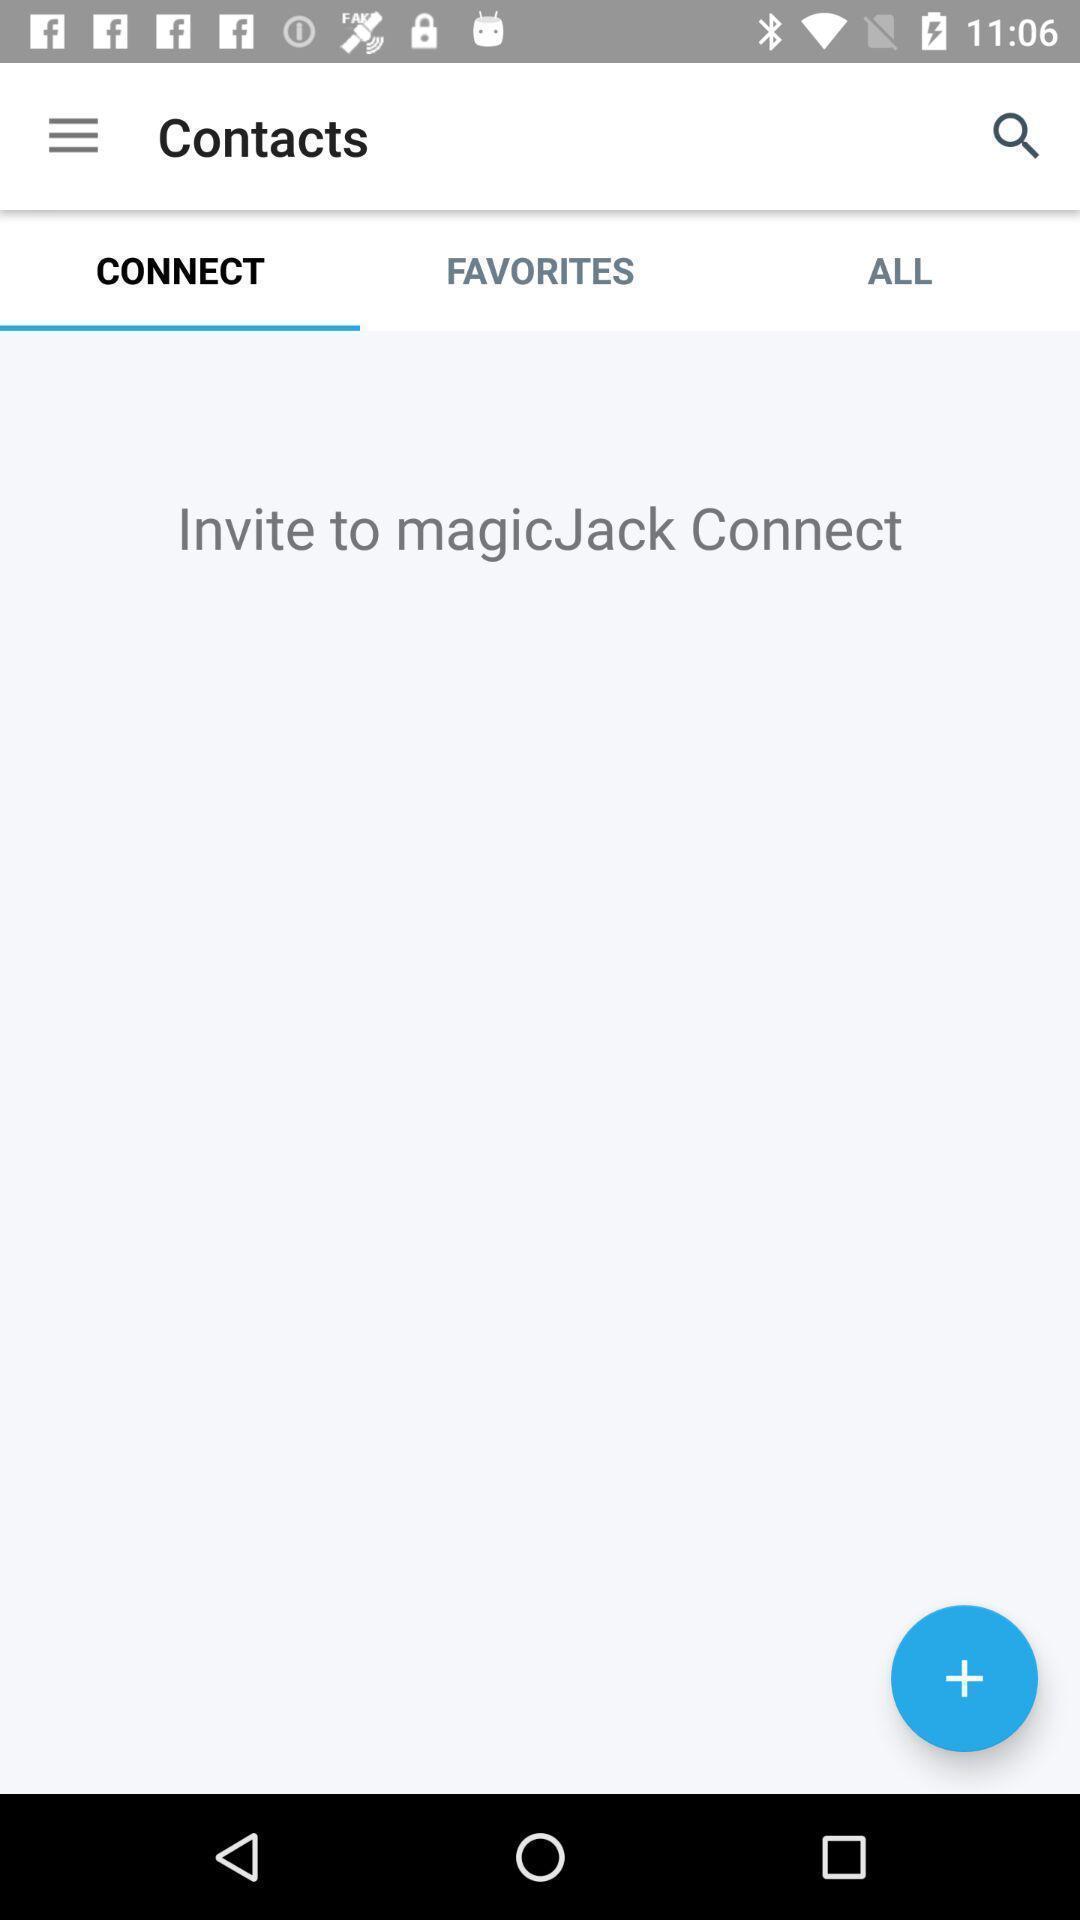Please provide a description for this image. Page shows to connect your contacts. 